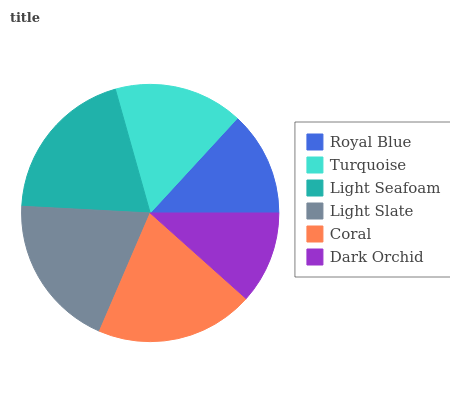Is Dark Orchid the minimum?
Answer yes or no. Yes. Is Coral the maximum?
Answer yes or no. Yes. Is Turquoise the minimum?
Answer yes or no. No. Is Turquoise the maximum?
Answer yes or no. No. Is Turquoise greater than Royal Blue?
Answer yes or no. Yes. Is Royal Blue less than Turquoise?
Answer yes or no. Yes. Is Royal Blue greater than Turquoise?
Answer yes or no. No. Is Turquoise less than Royal Blue?
Answer yes or no. No. Is Light Slate the high median?
Answer yes or no. Yes. Is Turquoise the low median?
Answer yes or no. Yes. Is Turquoise the high median?
Answer yes or no. No. Is Light Seafoam the low median?
Answer yes or no. No. 